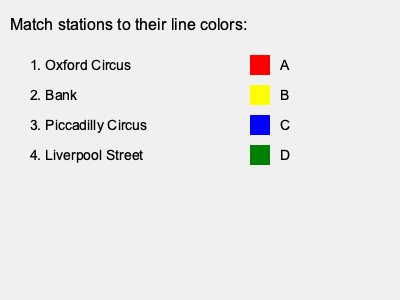Match the London Underground stations to their corresponding line colors. Provide your answer as a series of number-letter pairs (e.g., 1A, 2B, etc.). To match the London Underground stations to their corresponding line colors, we need to consider the primary lines serving each station:

1. Oxford Circus:
   - Served by the Central (red), Bakerloo (brown), and Victoria (light blue) lines
   - The most prominent color among these is red (Central line)
   - Match: 1A (red)

2. Bank:
   - Served by the Central (red), Northern (black), and Waterloo & City (turquoise) lines
   - The Central line (red) is the most recognizable here, but it's not an option
   - The closest match is the yellow line, which could represent the sub-surface Circle line that passes nearby at Monument
   - Match: 2B (yellow)

3. Piccadilly Circus:
   - Served by the Piccadilly (dark blue) and Bakerloo (brown) lines
   - The Piccadilly line's dark blue is the most prominent
   - Match: 3C (blue)

4. Liverpool Street:
   - Served by the Central (red), Circle (yellow), Hammersmith & City (pink), and Metropolitan (magenta) lines
   - The most prominent sub-surface line color is yellow (Circle line)
   - However, the green option likely represents the nearby Central line
   - Match: 4D (green)

Therefore, the correct matching is: 1A, 2B, 3C, 4D.
Answer: 1A, 2B, 3C, 4D 